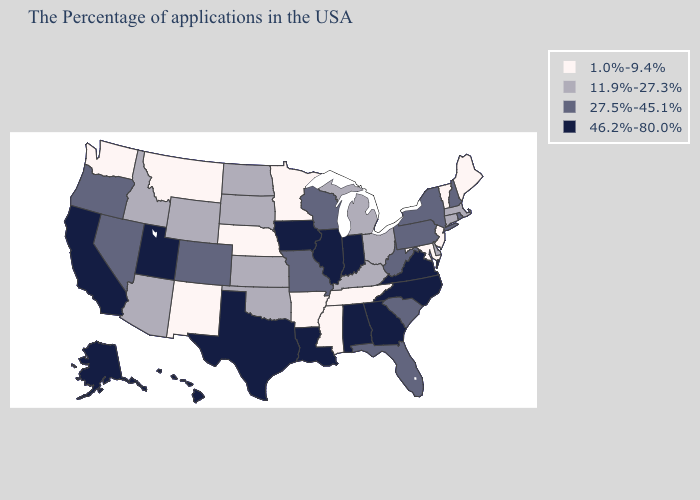Does Colorado have the lowest value in the USA?
Quick response, please. No. Does Maine have the lowest value in the Northeast?
Quick response, please. Yes. What is the lowest value in the USA?
Be succinct. 1.0%-9.4%. Name the states that have a value in the range 27.5%-45.1%?
Write a very short answer. Rhode Island, New Hampshire, New York, Pennsylvania, South Carolina, West Virginia, Florida, Wisconsin, Missouri, Colorado, Nevada, Oregon. Which states have the lowest value in the West?
Write a very short answer. New Mexico, Montana, Washington. What is the lowest value in the USA?
Be succinct. 1.0%-9.4%. Name the states that have a value in the range 46.2%-80.0%?
Quick response, please. Virginia, North Carolina, Georgia, Indiana, Alabama, Illinois, Louisiana, Iowa, Texas, Utah, California, Alaska, Hawaii. Name the states that have a value in the range 27.5%-45.1%?
Keep it brief. Rhode Island, New Hampshire, New York, Pennsylvania, South Carolina, West Virginia, Florida, Wisconsin, Missouri, Colorado, Nevada, Oregon. Name the states that have a value in the range 46.2%-80.0%?
Short answer required. Virginia, North Carolina, Georgia, Indiana, Alabama, Illinois, Louisiana, Iowa, Texas, Utah, California, Alaska, Hawaii. How many symbols are there in the legend?
Be succinct. 4. Name the states that have a value in the range 46.2%-80.0%?
Short answer required. Virginia, North Carolina, Georgia, Indiana, Alabama, Illinois, Louisiana, Iowa, Texas, Utah, California, Alaska, Hawaii. Does Minnesota have the highest value in the MidWest?
Answer briefly. No. Name the states that have a value in the range 46.2%-80.0%?
Short answer required. Virginia, North Carolina, Georgia, Indiana, Alabama, Illinois, Louisiana, Iowa, Texas, Utah, California, Alaska, Hawaii. Does Washington have the lowest value in the USA?
Give a very brief answer. Yes. 